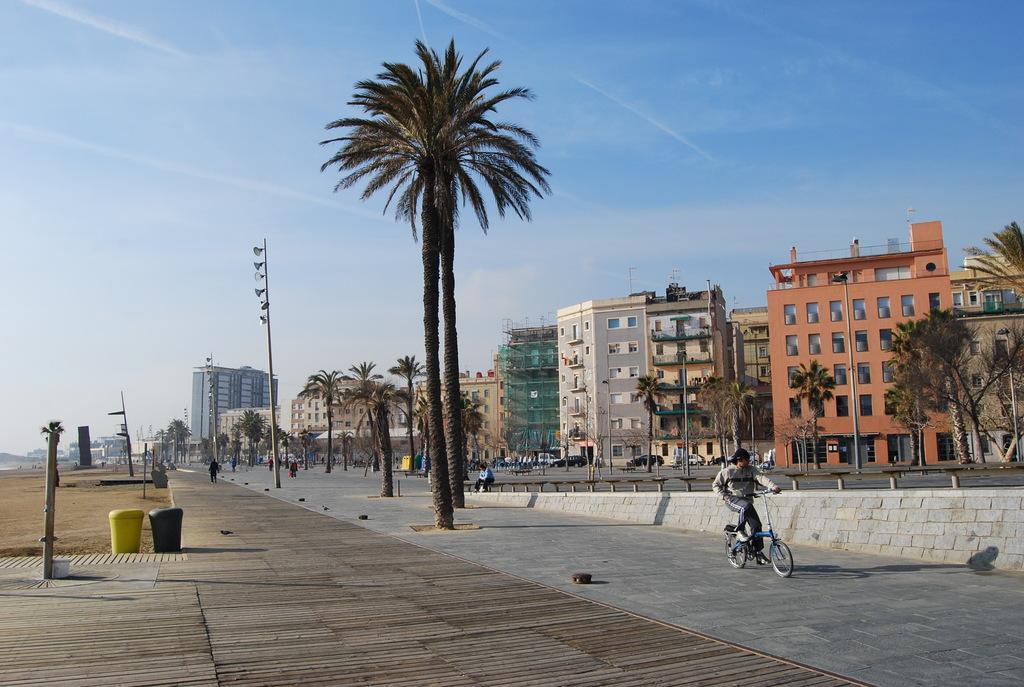Please provide a concise description of this image. In this image we can see buildings with windows, trees, vehicles, people, sand, poles, dustbin and in the background we can see the sky. 